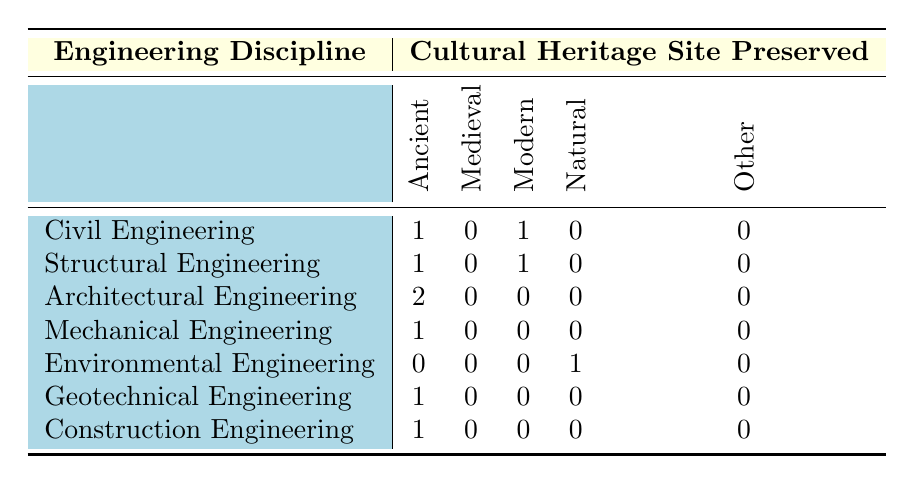What is the total number of ancient cultural heritage sites preserved in the table? There are three engineering disciplines corresponding to ancient cultural heritage sites: Civil Engineering (Eiffel Tower), Structural Engineering (Colosseum), and Geotechnical Engineering (Angkor Wat). Summing these gives a total of 3 ancient sites preserved.
Answer: 3 How many cultural heritage sites are preserved in total related to Architectural Engineering? Architectural Engineering is associated with two cultural heritage sites: Pyramids of Giza and Taj Mahal. Therefore, there are 2 cultural heritage sites preserved under this engineering discipline.
Answer: 2 Is there any cultural heritage site preserved that falls under the "Medieval" category? Examining the table, there are no cultural heritage sites listed under the Medieval category for any engineering disciplines. Therefore, the answer is no.
Answer: No Which engineering discipline has preserved the most number of cultural heritage sites? Analyzing the table, Architectural Engineering has preserved 2 sites (Pyramids of Giza and Taj Mahal), while Civil and Structural Engineering have each preserved 2 sites as well. However, no other discipline has more than 1. Thus, there are three disciplines (Civil, Structural, and Architectural Engineering) with the highest number of preserved sites, each having 2 or more.
Answer: Civil, Structural, and Architectural Engineering If we sum the number of preserved sites across all types of cultural heritage categories, what is the total? The totals for each category are: Ancient: 5, Medieval: 0, Modern: 3, Natural: 1, Other: 0. Summing these gives a total of 5 + 0 + 3 + 1 + 0 = 9 sites preserved across all categories.
Answer: 9 Does Environmental Engineering have any associated cultural heritage sites preserved? According to the table, Environmental Engineering is listed with the Great Barrier Reef as the only preservation, which categorizes it as a Natural site. Therefore, yes, there is a cultural heritage site preserved associated with this discipline.
Answer: Yes What is the ratio of ancient to modern cultural heritage sites preserved? There are 5 ancient sites and 3 modern sites. The ratio is 5:3, which can be expressed as a fraction or simplified to approximately 1.67 when calculated. Thus, the ancient to modern sites ratio is 5 to 3.
Answer: 5:3 How many engineering disciplines have preserved no cultural heritage sites in the medieval category? By analyzing the table, it shows that all engineering disciplines have 0 entries in the medieval category. Therefore, all 7 disciplines have preserved no sites in this category.
Answer: 7 Which cultural heritage site is preserved by Mechanical Engineering? According to the table, the cultural heritage site preserved by Mechanical Engineering is Machu Picchu. This can be directly referred from the preservation listing under Mechanical Engineering.
Answer: Machu Picchu 